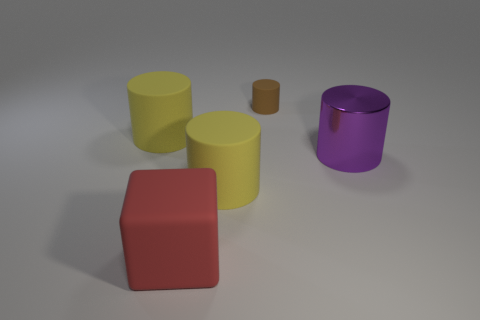Subtract all rubber cylinders. How many cylinders are left? 1 Subtract all brown cylinders. How many cylinders are left? 3 Add 4 tiny yellow metal things. How many objects exist? 9 Subtract all gray balls. How many cyan cylinders are left? 0 Subtract all cyan objects. Subtract all tiny brown rubber things. How many objects are left? 4 Add 1 matte blocks. How many matte blocks are left? 2 Add 3 small brown shiny cubes. How many small brown shiny cubes exist? 3 Subtract 2 yellow cylinders. How many objects are left? 3 Subtract all cylinders. How many objects are left? 1 Subtract 2 cylinders. How many cylinders are left? 2 